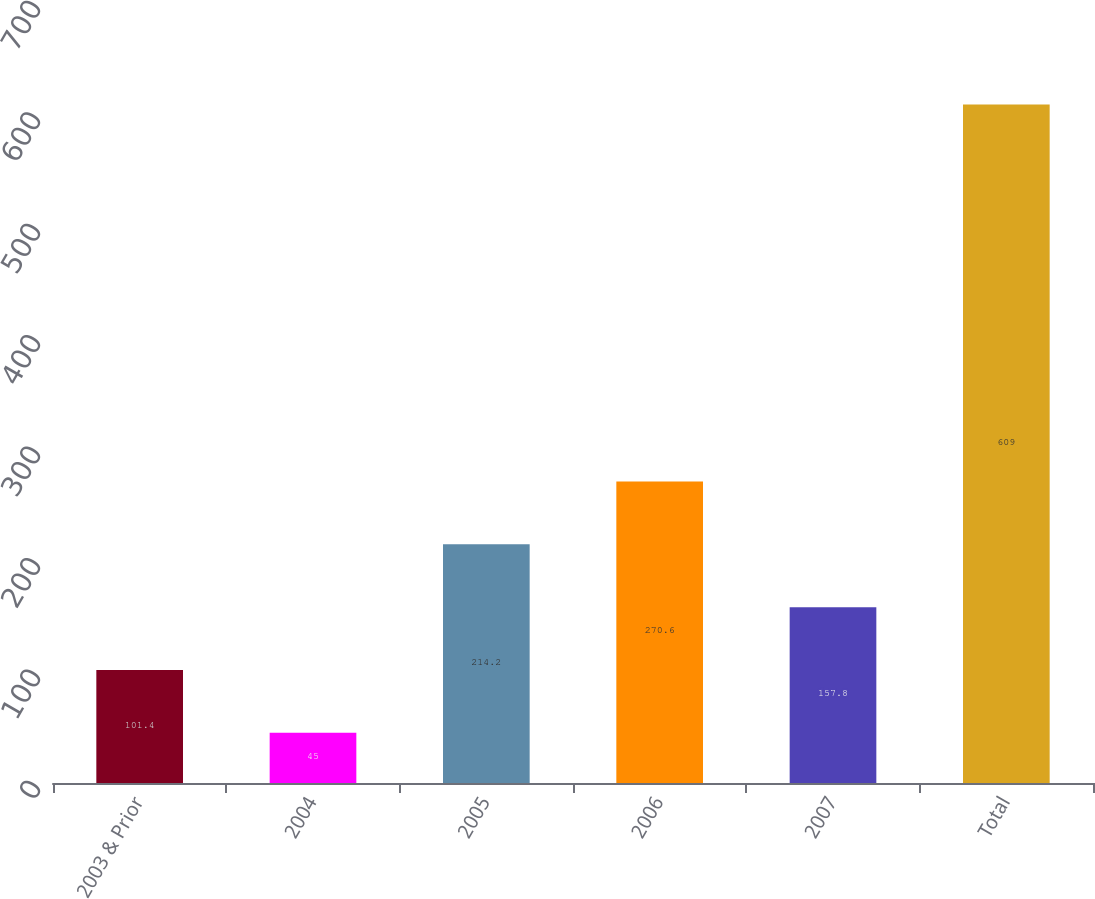Convert chart to OTSL. <chart><loc_0><loc_0><loc_500><loc_500><bar_chart><fcel>2003 & Prior<fcel>2004<fcel>2005<fcel>2006<fcel>2007<fcel>Total<nl><fcel>101.4<fcel>45<fcel>214.2<fcel>270.6<fcel>157.8<fcel>609<nl></chart> 